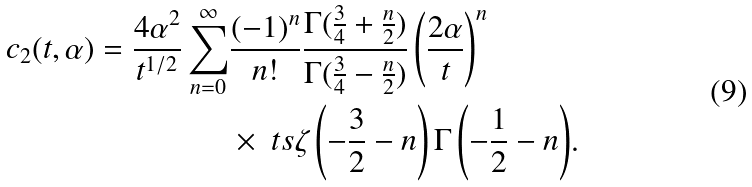<formula> <loc_0><loc_0><loc_500><loc_500>c _ { 2 } ( t , \alpha ) = \frac { 4 \alpha ^ { 2 } } { t ^ { 1 / 2 } } \sum _ { n = 0 } ^ { \infty } & \frac { ( - 1 ) ^ { n } } { n ! } \frac { \Gamma ( \frac { 3 } { 4 } + \frac { n } { 2 } ) } { \Gamma ( \frac { 3 } { 4 } - \frac { n } { 2 } ) } \left ( \frac { 2 \alpha } { t } \right ) ^ { n } \\ & \times { \ t s \zeta \left ( - \frac { 3 } { 2 } - n \right ) \Gamma \left ( - \frac { 1 } { 2 } - n \right ) } .</formula> 